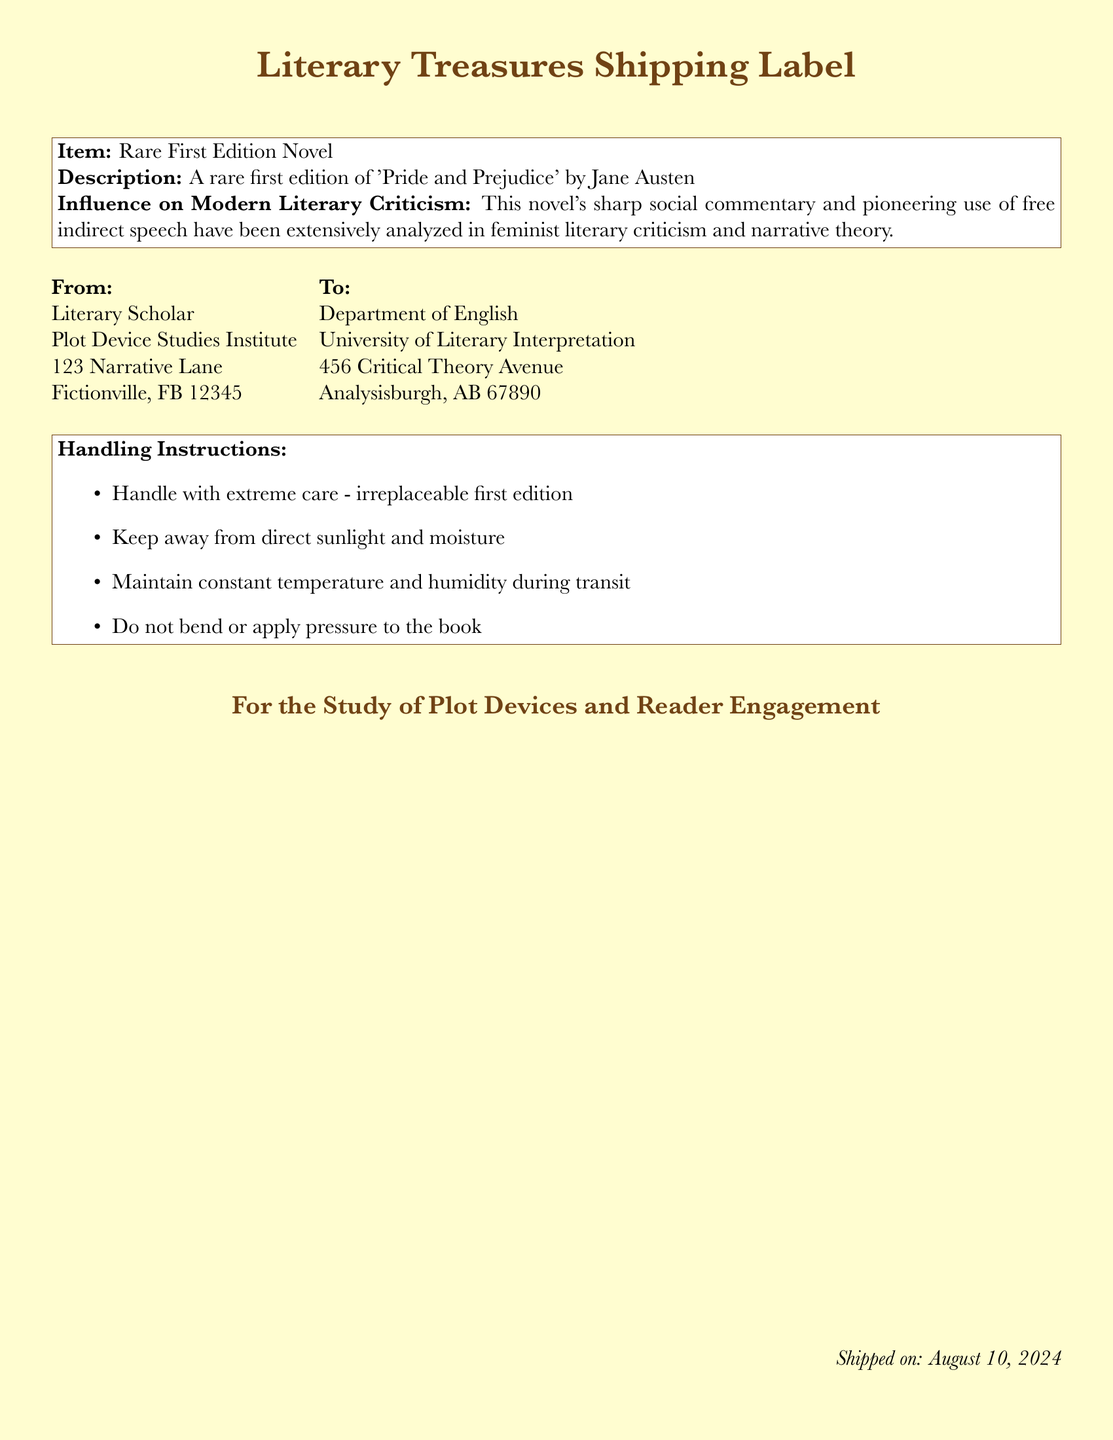What is the item being shipped? The item is specified in the document as a rare first edition novel.
Answer: Rare First Edition Novel Who is the sender of the shipment? The sender's information is included on the shipping label, indicating the Literary Scholar as the sender.
Answer: Literary Scholar What is the shipping date? The date of shipping is mentioned in the footer of the document, stated as today's date.
Answer: Today’s date What is the historical significance of the novel? The document outlines how the novel has been analyzed in feminist literary criticism and narrative theory.
Answer: Feminist literary criticism and narrative theory What is the recipient's address? The recipient's information is detailed in the shipping label, providing the full address for the Department of English.
Answer: 456 Critical Theory Avenue, Analysisburgh, AB 67890 What are the handling instructions for the item? The document includes specific instructions regarding the care of the rare first edition novel, asking for careful handling.
Answer: Handle with extreme care - irreplaceable first edition How many items are included in this shipment? It is only one item mentioned in the document, which is the novel.
Answer: One item What genre does the book belong to? The book title mentioned is 'Pride and Prejudice' which is recognized as a novel in the Romance genre.
Answer: Romance What is highlighted as a key aspect of the book's influence? The influence of the book on literary criticism is noted, particularly regarding its narrative techniques.
Answer: Free indirect speech What should be avoided during transit? The document specifies conditions that should be avoided for the sustainability of the book during transit.
Answer: Direct sunlight and moisture 